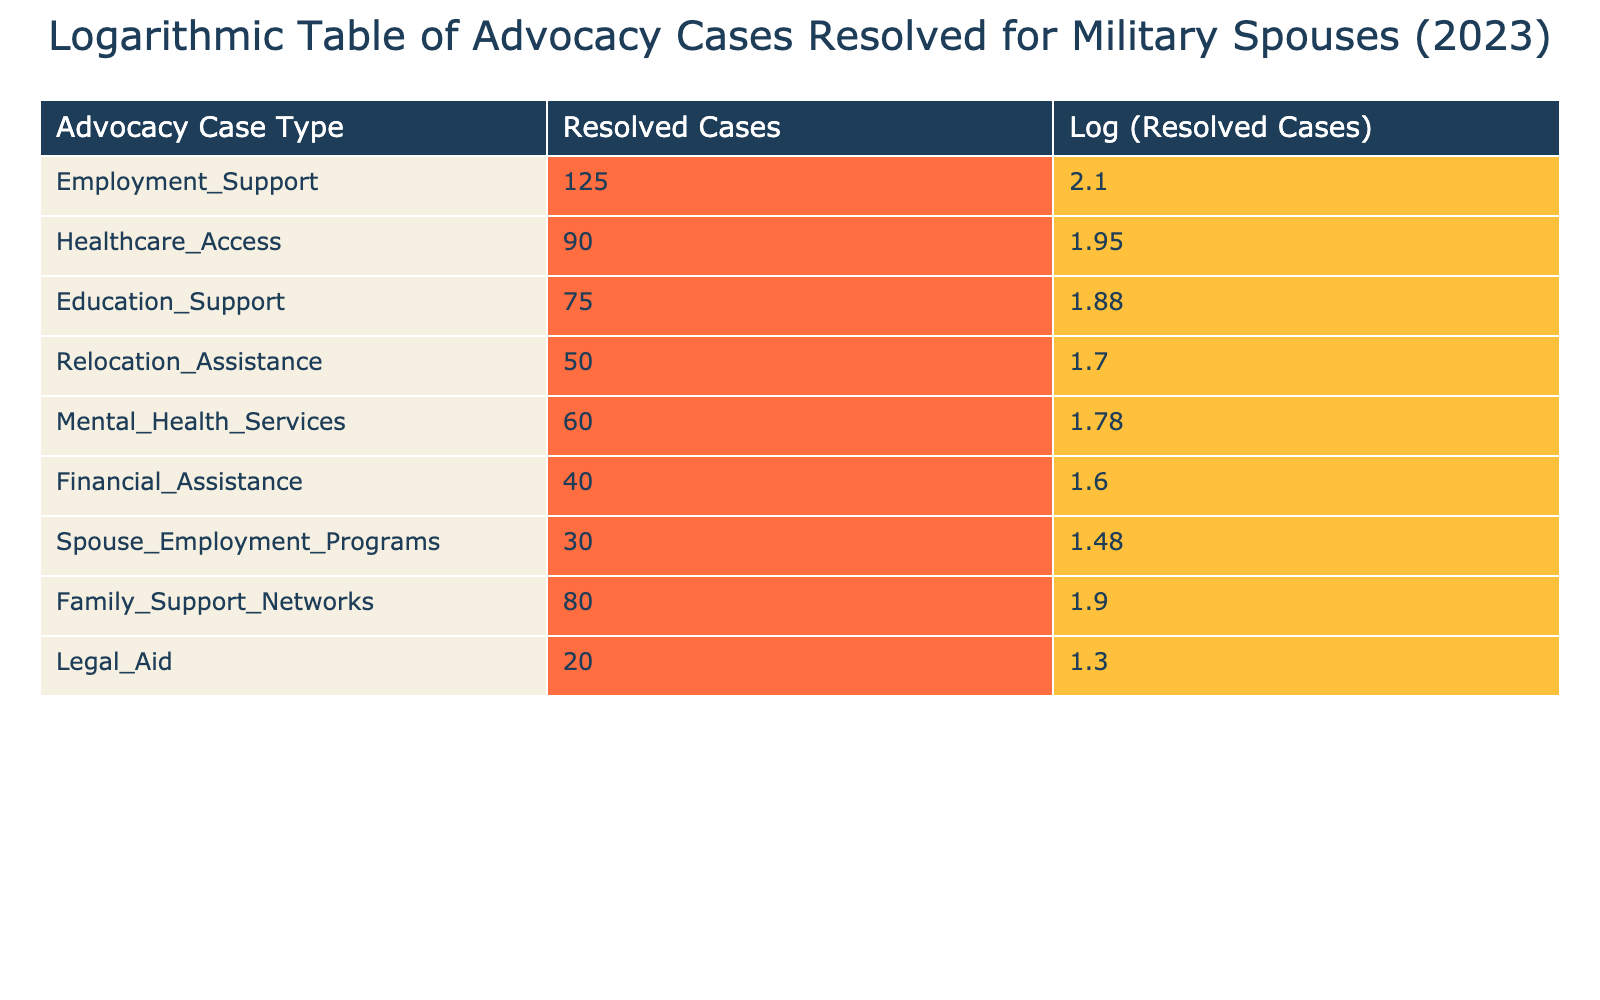What is the total number of resolved cases for Employment Support and Healthcare Access? To find the total, we need to look at the resolved cases for Employment Support, which is 125, and for Healthcare Access, which is 90. By adding them together: 125 + 90 = 215.
Answer: 215 Which advocacy case type had the least number of resolved cases in 2023? By examining the table, the advocacy case type with the least resolved cases is Legal Aid, which has 20 resolved cases.
Answer: Legal Aid What is the averaged number of resolved cases across all advocacy case types? To calculate the average, we sum all resolved cases: 125 + 90 + 75 + 50 + 60 + 40 + 30 + 80 + 20 = 570. Then we divide by the number of case types, which is 9: 570 / 9 = 63.33.
Answer: 63.33 Was the number of resolved Healthcare Access cases greater than the number of resolved Financial Assistance cases? The table shows that Healthcare Access has 90 resolved cases, whereas Financial Assistance has 40. Since 90 is greater than 40, the statement is true.
Answer: Yes How does the resolved cases for Spouse Employment Programs compare to the average of all advocacy case types? First, we identify the resolved cases for Spouse Employment Programs, which is 30. We already calculated the average as 63.33. Since 30 is less than 63.33, Spouse Employment Programs has fewer resolved cases than average.
Answer: Fewer What is the logarithmic value of resolved cases for Mental Health Services? The table shows that the resolved cases for Mental Health Services is 60. Using the logarithmic scale, we find log10(60), which is approximately 1.78 when rounded to two decimal places.
Answer: 1.78 Which advocacy case type had more resolved cases, Family Support Networks or Relocation Assistance? Looking at the table, Family Support Networks has 80 resolved cases and Relocation Assistance has 50. Comparing these two, 80 is greater than 50, indicating Family Support Networks had more resolved cases.
Answer: Family Support Networks If we consider only resolved cases over 70, how many types of advocacy cases fall under that category? The advocacy case types with resolved cases over 70 are Employment Support (125), Healthcare Access (90), Education Support (75), and Family Support Networks (80). Counting these, there are four advocacy case types in this category.
Answer: 4 